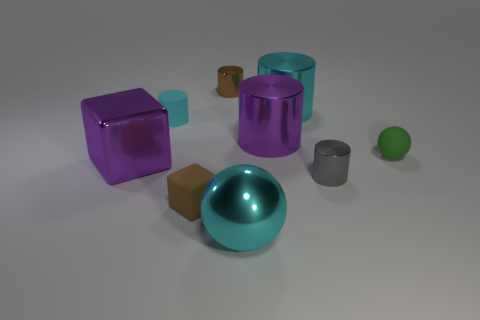Are there any other things that have the same size as the gray thing?
Provide a short and direct response. Yes. Are there more small things that are right of the small brown cylinder than rubber cylinders?
Make the answer very short. Yes. There is a shiny cylinder that is to the right of the cyan metallic cylinder; how many small brown objects are behind it?
Keep it short and to the point. 1. Are the brown thing in front of the tiny sphere and the cyan object left of the large cyan ball made of the same material?
Ensure brevity in your answer.  Yes. There is a tiny object that is the same color as the tiny cube; what material is it?
Your answer should be compact. Metal. What number of other gray things have the same shape as the gray shiny object?
Make the answer very short. 0. Does the big cyan cylinder have the same material as the brown object that is behind the tiny brown cube?
Ensure brevity in your answer.  Yes. What material is the gray cylinder that is the same size as the brown metal thing?
Offer a very short reply. Metal. Are there any blue cubes of the same size as the cyan rubber thing?
Give a very brief answer. No. The purple thing that is the same size as the purple metal cylinder is what shape?
Provide a succinct answer. Cube. 